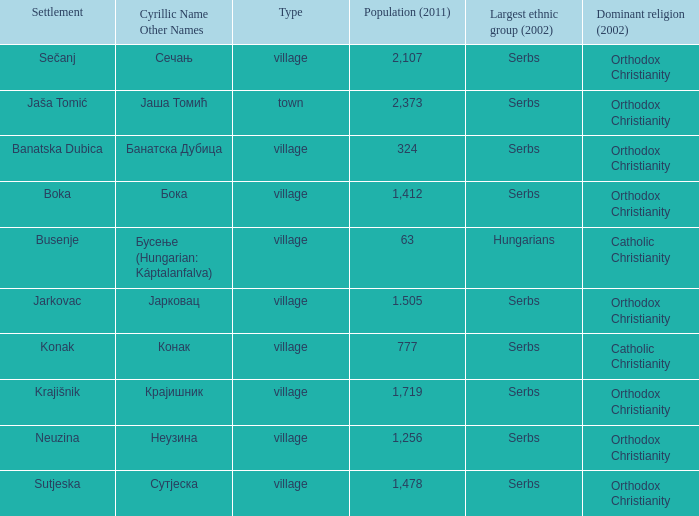Give me the full table as a dictionary. {'header': ['Settlement', 'Cyrillic Name Other Names', 'Type', 'Population (2011)', 'Largest ethnic group (2002)', 'Dominant religion (2002)'], 'rows': [['Sečanj', 'Сечањ', 'village', '2,107', 'Serbs', 'Orthodox Christianity'], ['Jaša Tomić', 'Јаша Томић', 'town', '2,373', 'Serbs', 'Orthodox Christianity'], ['Banatska Dubica', 'Банатска Дубица', 'village', '324', 'Serbs', 'Orthodox Christianity'], ['Boka', 'Бока', 'village', '1,412', 'Serbs', 'Orthodox Christianity'], ['Busenje', 'Бусење (Hungarian: Káptalanfalva)', 'village', '63', 'Hungarians', 'Catholic Christianity'], ['Jarkovac', 'Јарковац', 'village', '1.505', 'Serbs', 'Orthodox Christianity'], ['Konak', 'Конак', 'village', '777', 'Serbs', 'Catholic Christianity'], ['Krajišnik', 'Крајишник', 'village', '1,719', 'Serbs', 'Orthodox Christianity'], ['Neuzina', 'Неузина', 'village', '1,256', 'Serbs', 'Orthodox Christianity'], ['Sutjeska', 'Сутјеска', 'village', '1,478', 'Serbs', 'Orthodox Christianity']]} Which town possesses a population of 777? Конак. 